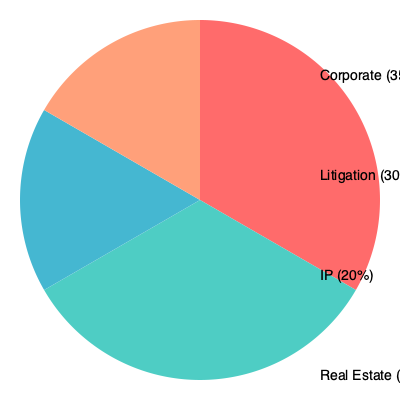Based on the pie chart showing the market share of different legal practices, which two areas combined account for 65% of the total market share? To solve this question, we need to analyze the percentages given for each legal practice area and find the combination that adds up to 65%. Let's go through this step-by-step:

1. The pie chart shows four legal practice areas:
   - Corporate: 35%
   - Litigation: 30%
   - IP (Intellectual Property): 20%
   - Real Estate: 15%

2. We need to find two areas that, when combined, equal 65%.

3. Let's consider the possible combinations:
   - Corporate + Litigation: 35% + 30% = 65%
   - Corporate + IP: 35% + 20% = 55%
   - Corporate + Real Estate: 35% + 15% = 50%
   - Litigation + IP: 30% + 20% = 50%
   - Litigation + Real Estate: 30% + 15% = 45%
   - IP + Real Estate: 20% + 15% = 35%

4. From these combinations, we can see that only Corporate and Litigation together account for 65% of the total market share.

Therefore, the two areas that combined account for 65% of the total market share are Corporate and Litigation.
Answer: Corporate and Litigation 